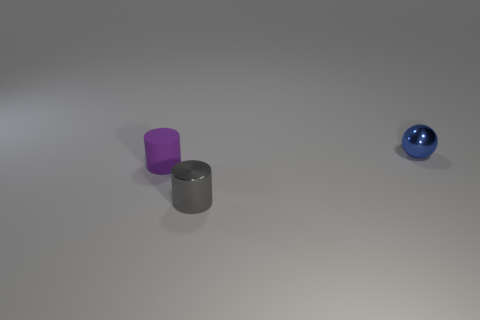Is there anything else that is made of the same material as the purple cylinder?
Offer a terse response. No. What number of other things are the same size as the purple cylinder?
Your answer should be very brief. 2. The small thing behind the cylinder that is left of the gray shiny cylinder is made of what material?
Offer a very short reply. Metal. Are there any metal things right of the small matte cylinder?
Your response must be concise. Yes. Is the number of rubber objects right of the small purple rubber object greater than the number of small objects?
Your response must be concise. No. Is there a tiny metallic thing of the same color as the shiny sphere?
Give a very brief answer. No. There is a cylinder that is the same size as the matte thing; what color is it?
Provide a short and direct response. Gray. There is a thing that is behind the tiny purple object; are there any purple rubber objects to the right of it?
Offer a very short reply. No. There is a small cylinder on the left side of the tiny gray object; what material is it?
Give a very brief answer. Rubber. Is the cylinder to the left of the tiny gray cylinder made of the same material as the cylinder that is on the right side of the small rubber object?
Your response must be concise. No. 